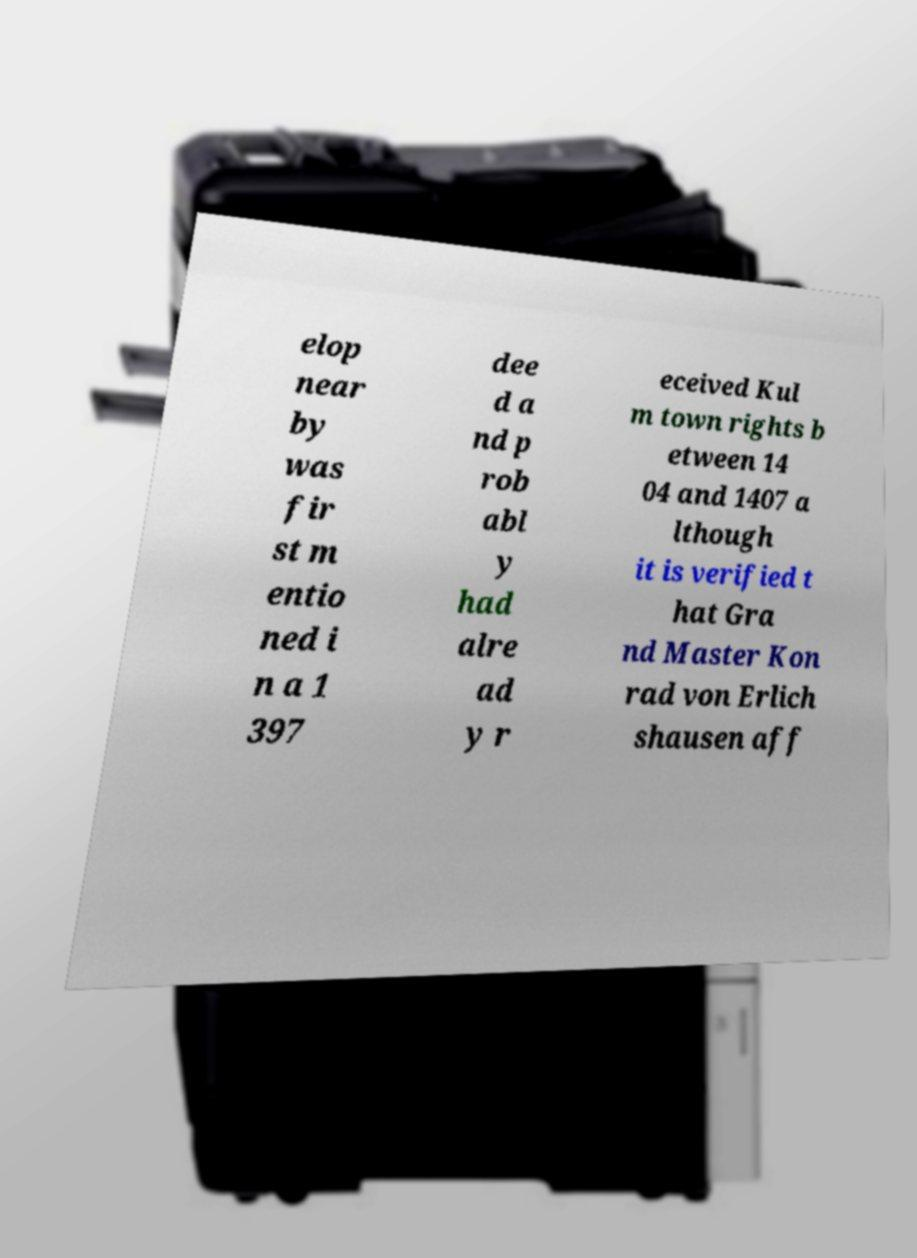Can you accurately transcribe the text from the provided image for me? elop near by was fir st m entio ned i n a 1 397 dee d a nd p rob abl y had alre ad y r eceived Kul m town rights b etween 14 04 and 1407 a lthough it is verified t hat Gra nd Master Kon rad von Erlich shausen aff 